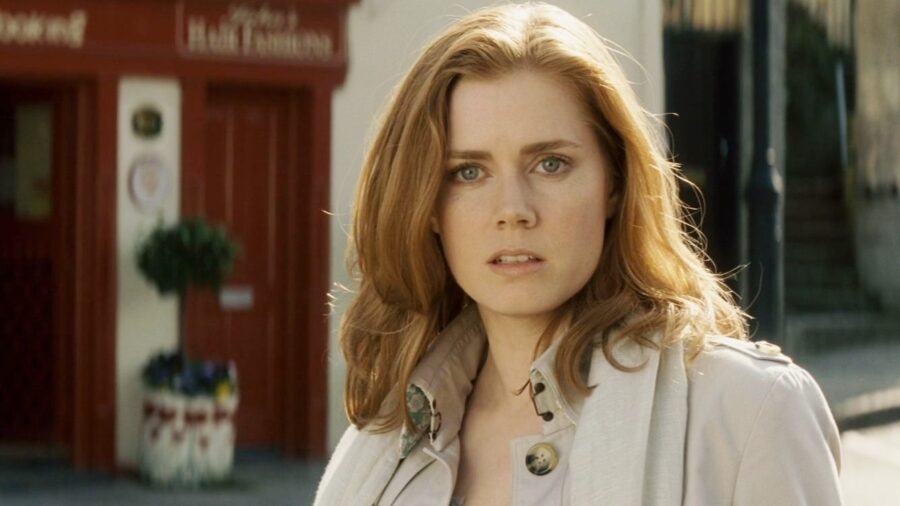Write a detailed description of the given image. In this captivating image, a renowned woman stands on a city street against a backdrop of a lively red storefront. The window of the storefront features a charming green plant, adding a touch of nature to the urban scene. She is adorned in a sophisticated beige trench coat, accentuated with a brooch that lends an air of elegance to her look. Her lush, wavy red hair cascades over her shoulders, harmonizing beautifully with her surroundings. Her expression is one of deep contemplation, with her eyes gazing to the side, conveying a sense of introspection amidst the bustling city life. 